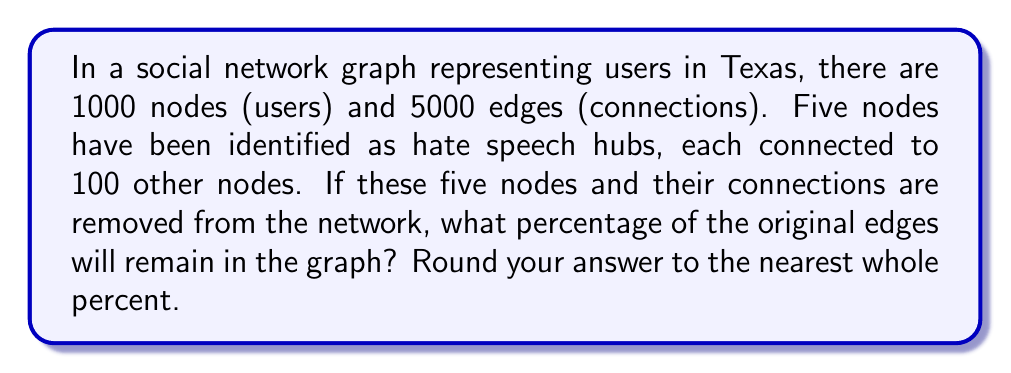Help me with this question. To solve this problem, we need to follow these steps:

1. Calculate the total number of edges that will be removed:
   Each hate speech hub is connected to 100 nodes, so it has 100 edges.
   Total edges to be removed = $5 \times 100 = 500$ edges

2. Calculate the number of edges remaining after removal:
   Original edges = 5000
   Remaining edges = $5000 - 500 = 4500$

3. Calculate the percentage of original edges that remain:
   Percentage = $\frac{\text{Remaining edges}}{\text{Original edges}} \times 100\%$
   
   $$\text{Percentage} = \frac{4500}{5000} \times 100\% = 0.9 \times 100\% = 90\%$$

4. Round to the nearest whole percent:
   90% is already a whole number, so no rounding is necessary.

This solution demonstrates how removing a small number of highly connected nodes (in this case, hate speech hubs) can have a significant impact on the overall structure of the network. By removing just 5 nodes out of 1000, we've eliminated 10% of all connections in the network, potentially disrupting the spread of hate speech.
Answer: 90% 